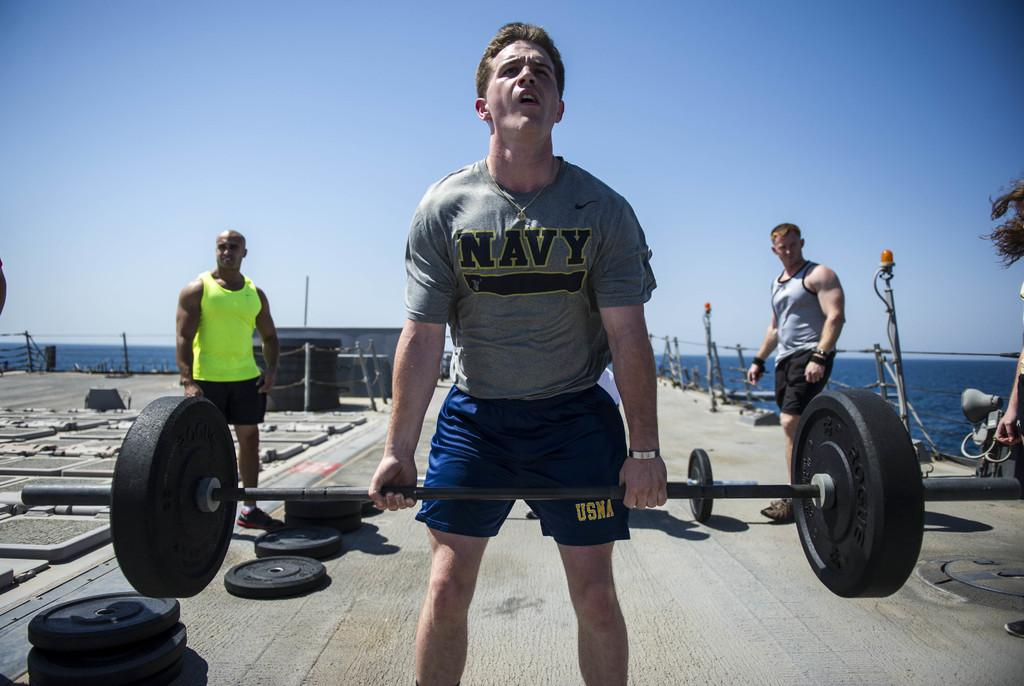<image>
Write a terse but informative summary of the picture. Three well built men stand outside near the water, one wearing a Navy t-shirt lifting a heavy weight bar. 